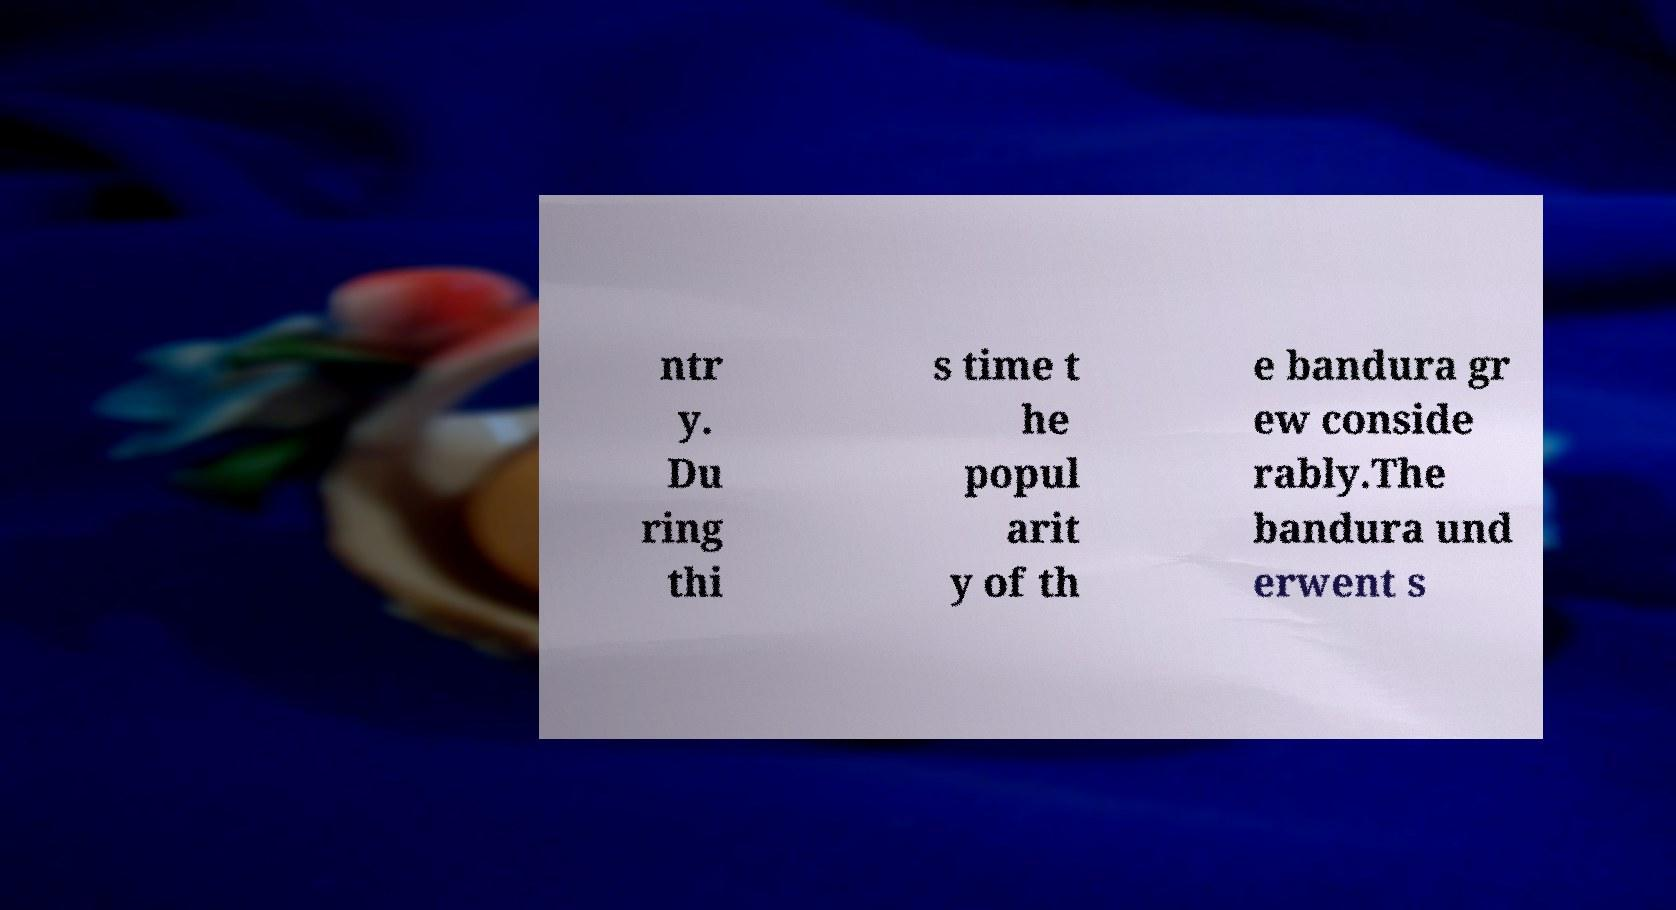Could you assist in decoding the text presented in this image and type it out clearly? ntr y. Du ring thi s time t he popul arit y of th e bandura gr ew conside rably.The bandura und erwent s 